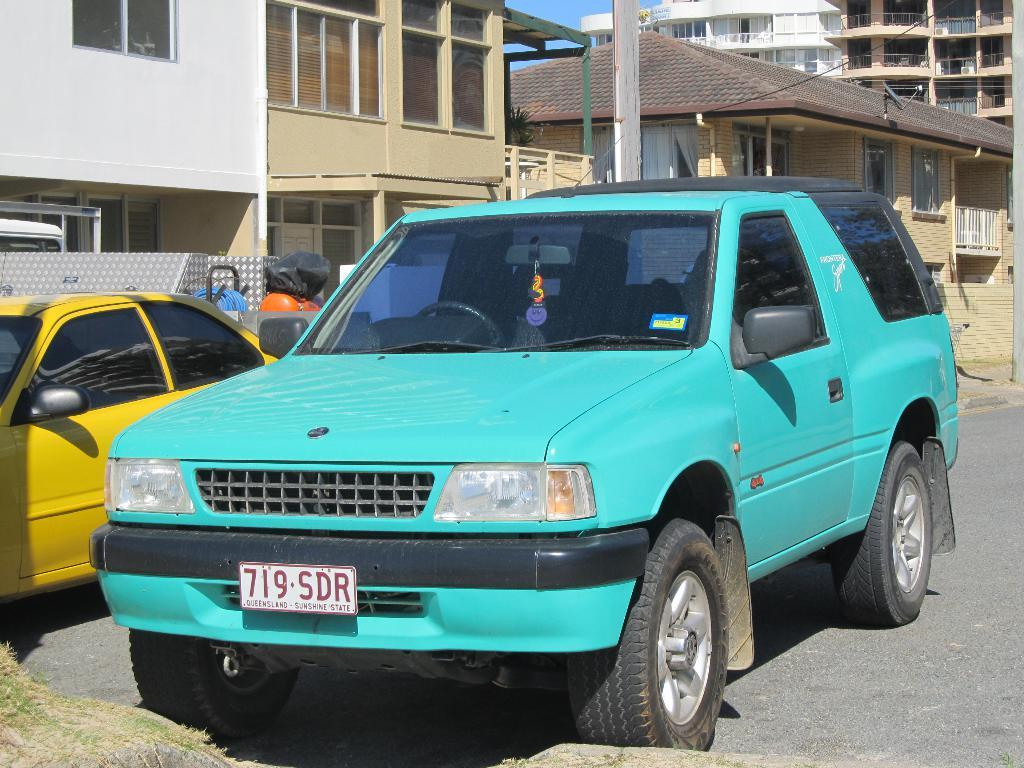<image>
Present a compact description of the photo's key features. Parking space behind a building with a teal SUV from Queensland. 